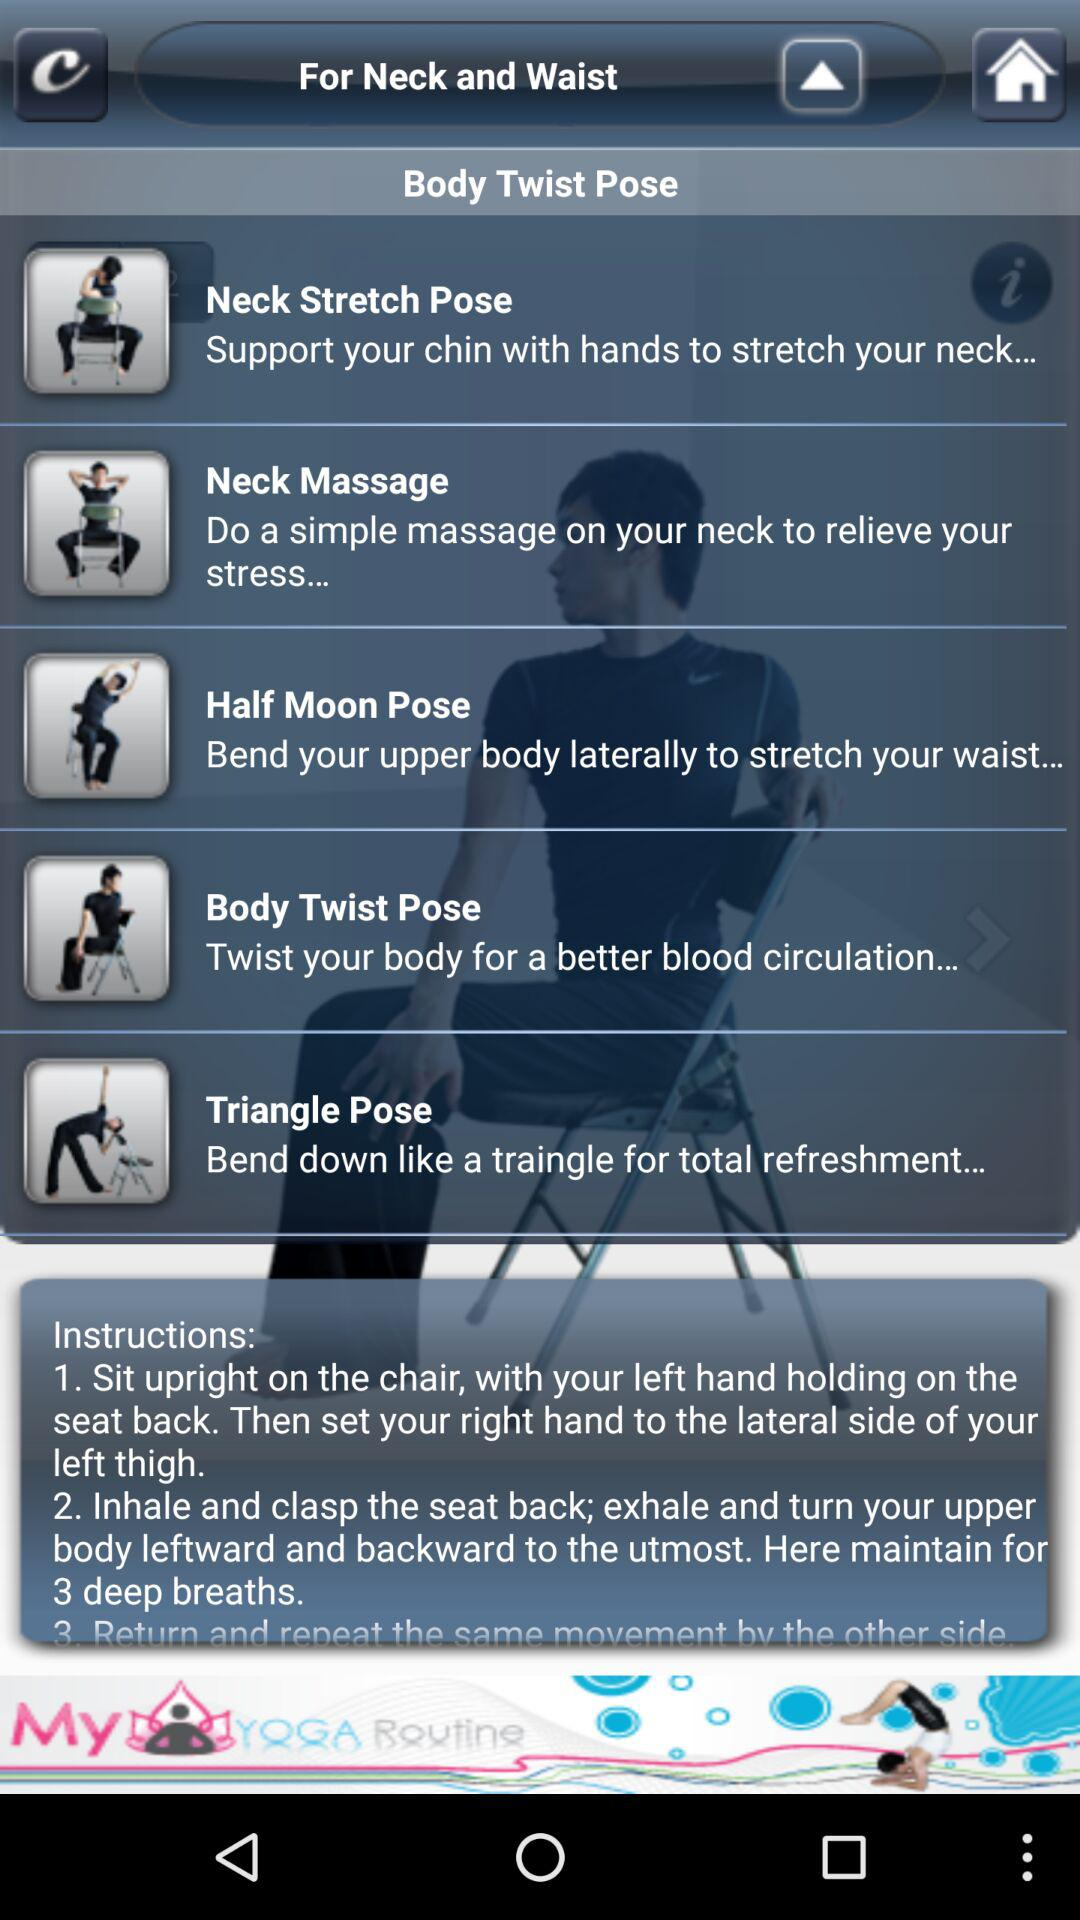Which pose is suitable for stretching the neck? The pose that is suitable for stretching the neck is "Neck Stretch Pose". 